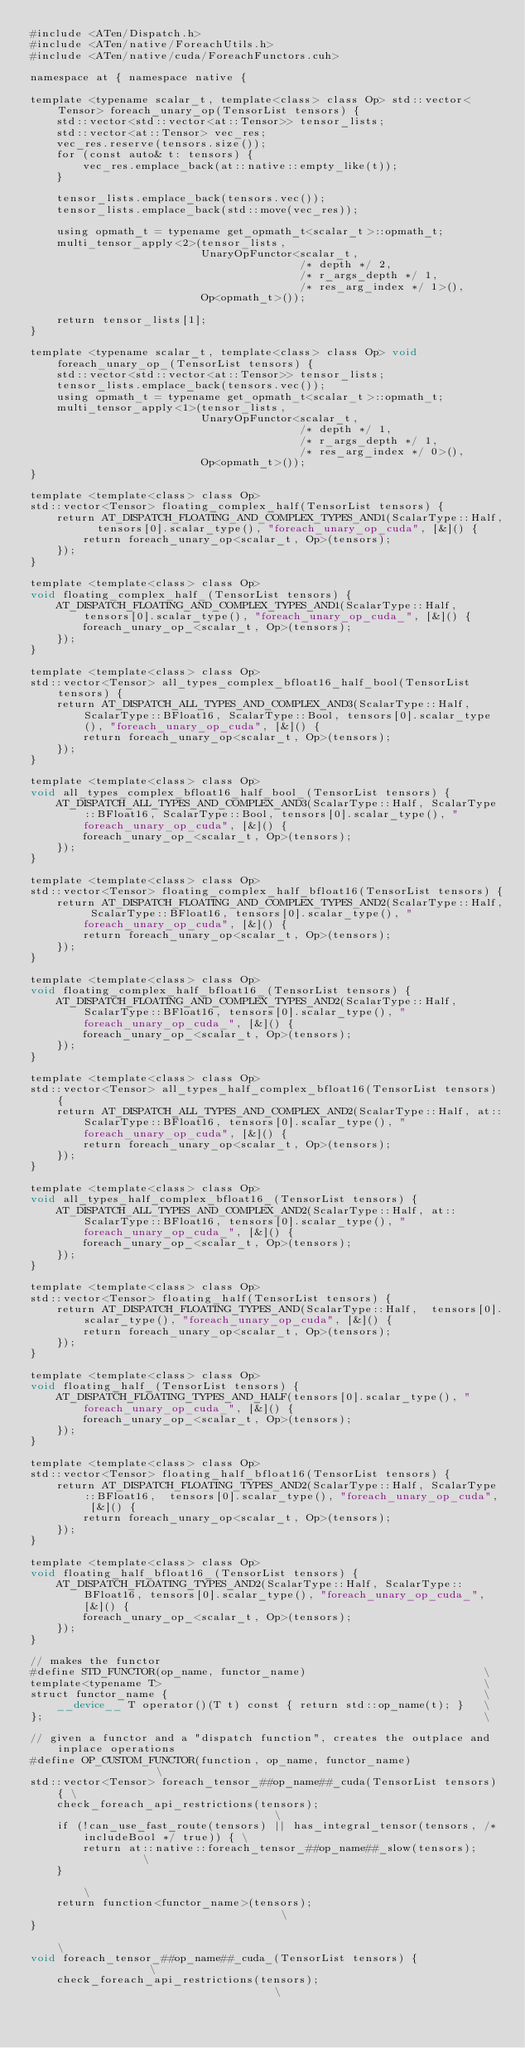Convert code to text. <code><loc_0><loc_0><loc_500><loc_500><_Cuda_>#include <ATen/Dispatch.h>
#include <ATen/native/ForeachUtils.h>
#include <ATen/native/cuda/ForeachFunctors.cuh>

namespace at { namespace native {

template <typename scalar_t, template<class> class Op> std::vector<Tensor> foreach_unary_op(TensorList tensors) {
    std::vector<std::vector<at::Tensor>> tensor_lists;
    std::vector<at::Tensor> vec_res;
    vec_res.reserve(tensors.size());
    for (const auto& t: tensors) {
        vec_res.emplace_back(at::native::empty_like(t));
    }

    tensor_lists.emplace_back(tensors.vec());
    tensor_lists.emplace_back(std::move(vec_res));

    using opmath_t = typename get_opmath_t<scalar_t>::opmath_t;
    multi_tensor_apply<2>(tensor_lists,
                          UnaryOpFunctor<scalar_t,
                                         /* depth */ 2,
                                         /* r_args_depth */ 1,
                                         /* res_arg_index */ 1>(),
                          Op<opmath_t>());

    return tensor_lists[1];
}

template <typename scalar_t, template<class> class Op> void foreach_unary_op_(TensorList tensors) {
    std::vector<std::vector<at::Tensor>> tensor_lists;
    tensor_lists.emplace_back(tensors.vec());
    using opmath_t = typename get_opmath_t<scalar_t>::opmath_t;
    multi_tensor_apply<1>(tensor_lists,
                          UnaryOpFunctor<scalar_t,
                                         /* depth */ 1,
                                         /* r_args_depth */ 1,
                                         /* res_arg_index */ 0>(),
                          Op<opmath_t>());
}

template <template<class> class Op>
std::vector<Tensor> floating_complex_half(TensorList tensors) {
    return AT_DISPATCH_FLOATING_AND_COMPLEX_TYPES_AND1(ScalarType::Half,  tensors[0].scalar_type(), "foreach_unary_op_cuda", [&]() {
        return foreach_unary_op<scalar_t, Op>(tensors);
    });
}

template <template<class> class Op>
void floating_complex_half_(TensorList tensors) {
    AT_DISPATCH_FLOATING_AND_COMPLEX_TYPES_AND1(ScalarType::Half, tensors[0].scalar_type(), "foreach_unary_op_cuda_", [&]() {
        foreach_unary_op_<scalar_t, Op>(tensors);
    });
}

template <template<class> class Op>
std::vector<Tensor> all_types_complex_bfloat16_half_bool(TensorList tensors) {
    return AT_DISPATCH_ALL_TYPES_AND_COMPLEX_AND3(ScalarType::Half, ScalarType::BFloat16, ScalarType::Bool, tensors[0].scalar_type(), "foreach_unary_op_cuda", [&]() {
        return foreach_unary_op<scalar_t, Op>(tensors);
    });
}

template <template<class> class Op>
void all_types_complex_bfloat16_half_bool_(TensorList tensors) {
    AT_DISPATCH_ALL_TYPES_AND_COMPLEX_AND3(ScalarType::Half, ScalarType::BFloat16, ScalarType::Bool, tensors[0].scalar_type(), "foreach_unary_op_cuda", [&]() {
        foreach_unary_op_<scalar_t, Op>(tensors);
    });
}

template <template<class> class Op>
std::vector<Tensor> floating_complex_half_bfloat16(TensorList tensors) {
    return AT_DISPATCH_FLOATING_AND_COMPLEX_TYPES_AND2(ScalarType::Half, ScalarType::BFloat16, tensors[0].scalar_type(), "foreach_unary_op_cuda", [&]() {
        return foreach_unary_op<scalar_t, Op>(tensors);
    });
}

template <template<class> class Op>
void floating_complex_half_bfloat16_(TensorList tensors) {
    AT_DISPATCH_FLOATING_AND_COMPLEX_TYPES_AND2(ScalarType::Half, ScalarType::BFloat16, tensors[0].scalar_type(), "foreach_unary_op_cuda_", [&]() {
        foreach_unary_op_<scalar_t, Op>(tensors);
    });
}

template <template<class> class Op>
std::vector<Tensor> all_types_half_complex_bfloat16(TensorList tensors) {
    return AT_DISPATCH_ALL_TYPES_AND_COMPLEX_AND2(ScalarType::Half, at::ScalarType::BFloat16, tensors[0].scalar_type(), "foreach_unary_op_cuda", [&]() {
        return foreach_unary_op<scalar_t, Op>(tensors);
    });
}

template <template<class> class Op>
void all_types_half_complex_bfloat16_(TensorList tensors) {
    AT_DISPATCH_ALL_TYPES_AND_COMPLEX_AND2(ScalarType::Half, at::ScalarType::BFloat16, tensors[0].scalar_type(), "foreach_unary_op_cuda_", [&]() {
        foreach_unary_op_<scalar_t, Op>(tensors);
    });
}

template <template<class> class Op>
std::vector<Tensor> floating_half(TensorList tensors) {
    return AT_DISPATCH_FLOATING_TYPES_AND(ScalarType::Half,  tensors[0].scalar_type(), "foreach_unary_op_cuda", [&]() {
        return foreach_unary_op<scalar_t, Op>(tensors);
    });
}

template <template<class> class Op>
void floating_half_(TensorList tensors) {
    AT_DISPATCH_FLOATING_TYPES_AND_HALF(tensors[0].scalar_type(), "foreach_unary_op_cuda_", [&]() {
        foreach_unary_op_<scalar_t, Op>(tensors);
    });
}

template <template<class> class Op>
std::vector<Tensor> floating_half_bfloat16(TensorList tensors) {
    return AT_DISPATCH_FLOATING_TYPES_AND2(ScalarType::Half, ScalarType::BFloat16,  tensors[0].scalar_type(), "foreach_unary_op_cuda", [&]() {
        return foreach_unary_op<scalar_t, Op>(tensors);
    });
}

template <template<class> class Op>
void floating_half_bfloat16_(TensorList tensors) {
    AT_DISPATCH_FLOATING_TYPES_AND2(ScalarType::Half, ScalarType::BFloat16, tensors[0].scalar_type(), "foreach_unary_op_cuda_", [&]() {
        foreach_unary_op_<scalar_t, Op>(tensors);
    });
}

// makes the functor
#define STD_FUNCTOR(op_name, functor_name)                           \
template<typename T>                                                 \
struct functor_name {                                                \
    __device__ T operator()(T t) const { return std::op_name(t); }   \
};                                                                   \

// given a functor and a "dispatch function", creates the outplace and inplace operations
#define OP_CUSTOM_FUNCTOR(function, op_name, functor_name)                \
std::vector<Tensor> foreach_tensor_##op_name##_cuda(TensorList tensors) { \
    check_foreach_api_restrictions(tensors);                              \
    if (!can_use_fast_route(tensors) || has_integral_tensor(tensors, /* includeBool */ true)) { \
        return at::native::foreach_tensor_##op_name##_slow(tensors);      \
    }                                                                     \
    return function<functor_name>(tensors);                               \
}                                                                         \
void foreach_tensor_##op_name##_cuda_(TensorList tensors) {               \
    check_foreach_api_restrictions(tensors);                              \</code> 